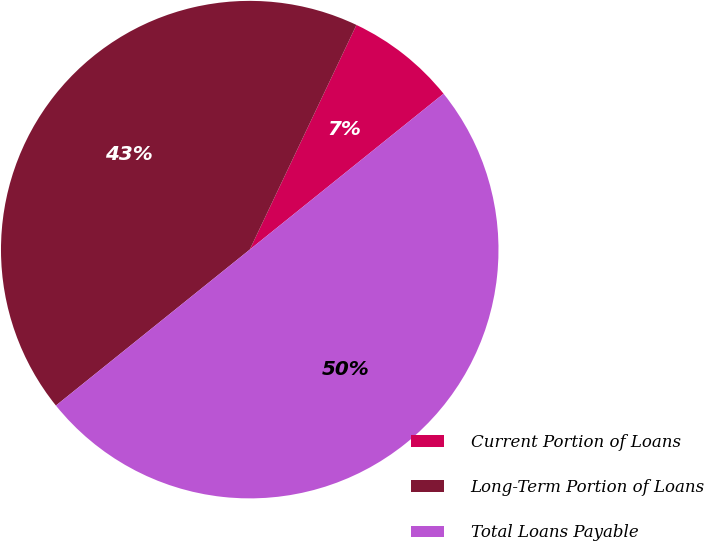<chart> <loc_0><loc_0><loc_500><loc_500><pie_chart><fcel>Current Portion of Loans<fcel>Long-Term Portion of Loans<fcel>Total Loans Payable<nl><fcel>7.16%<fcel>42.84%<fcel>50.0%<nl></chart> 